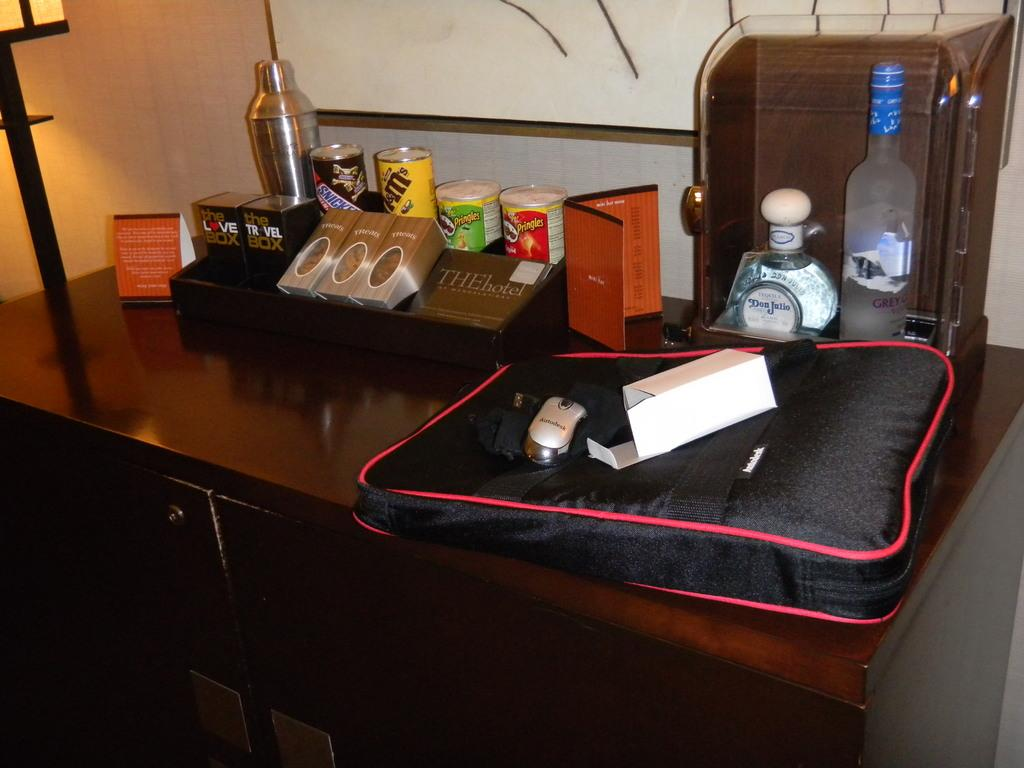What piece of furniture is present in the image? There is a table in the image. What object is placed on the table? There is a bag, a mouse, a box, a bottle, cards, and tins on the table. What can be seen in the background of the image? There is a wall visible in the background. What type of body is visible in the image? There is no body present in the image; it only features inanimate objects on a table. 